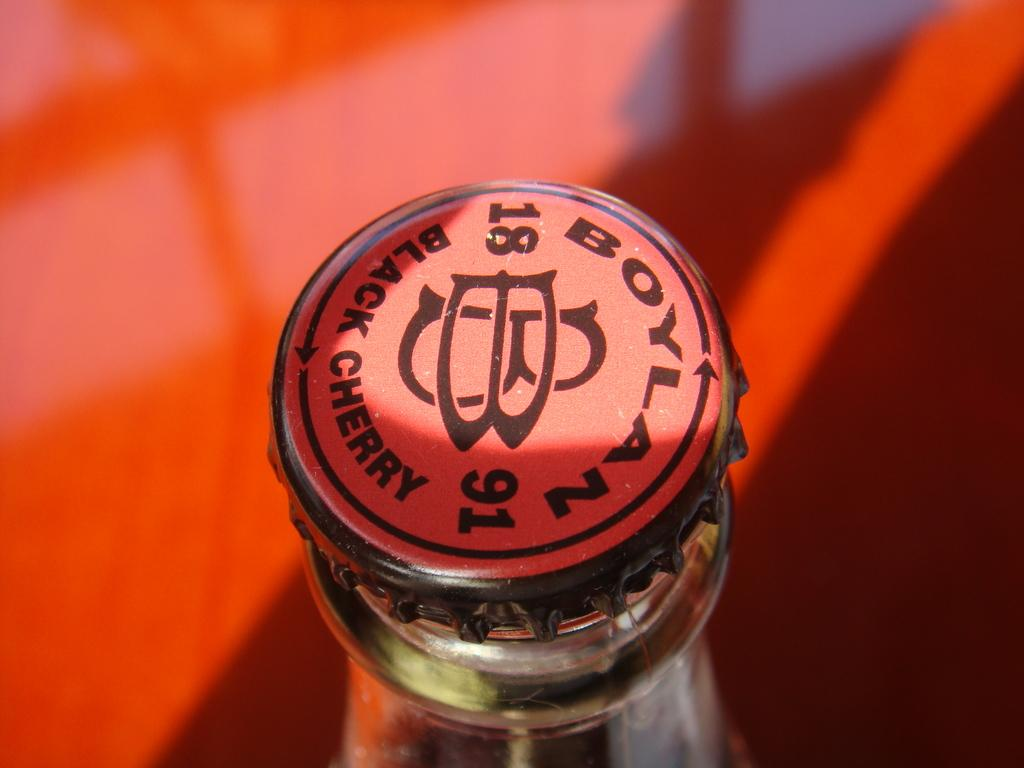What object is present in the image that has writing on it? There is a bottle cap in the image, and it has "black curry" written on it. What type of ice can be seen melting in the image? There is no ice present in the image. What kind of bait is visible in the image? There is no bait present in the image. 